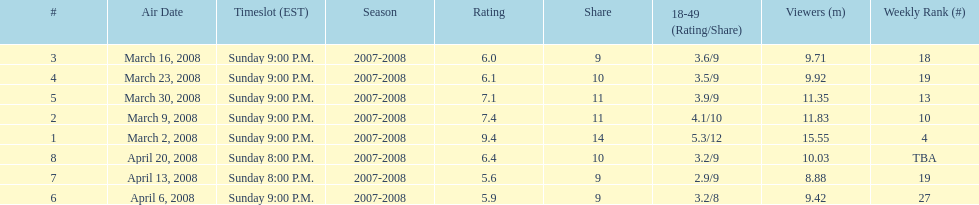What episode had the highest rating? March 2, 2008. 